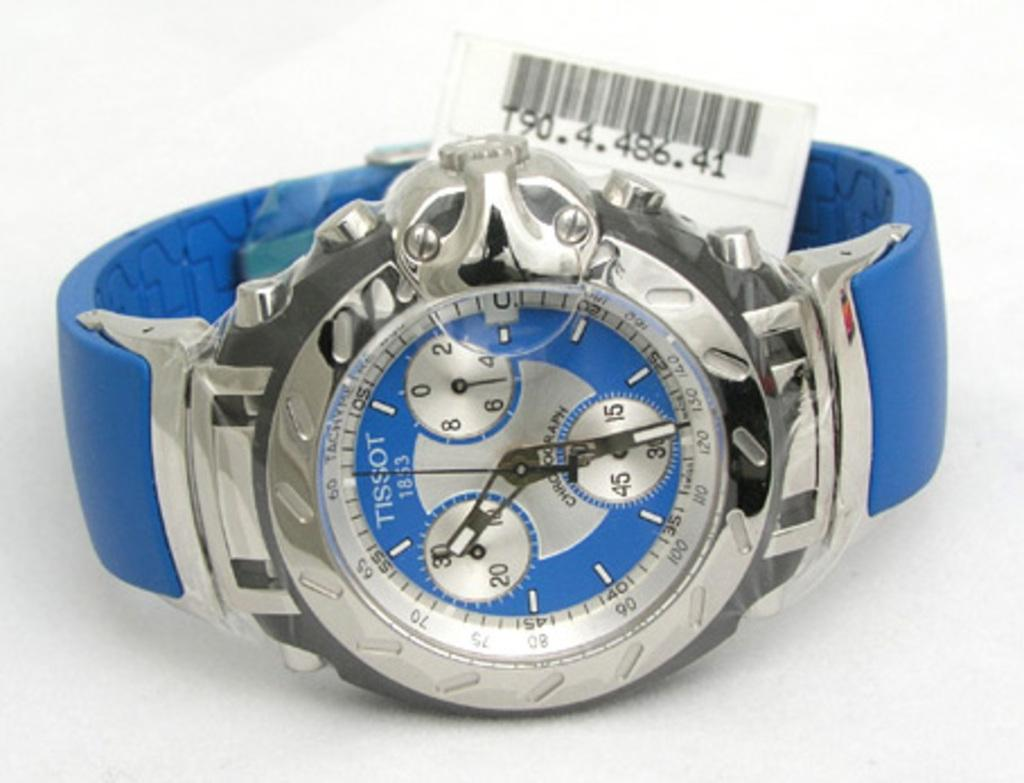<image>
Give a short and clear explanation of the subsequent image. Blue and silver stopwatch with a tag on it made by Tissot. 